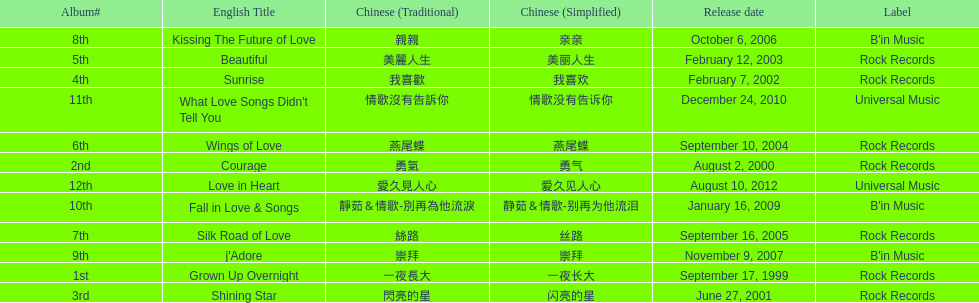Which was the only album to be released by b'in music in an even-numbered year? Kissing The Future of Love. 